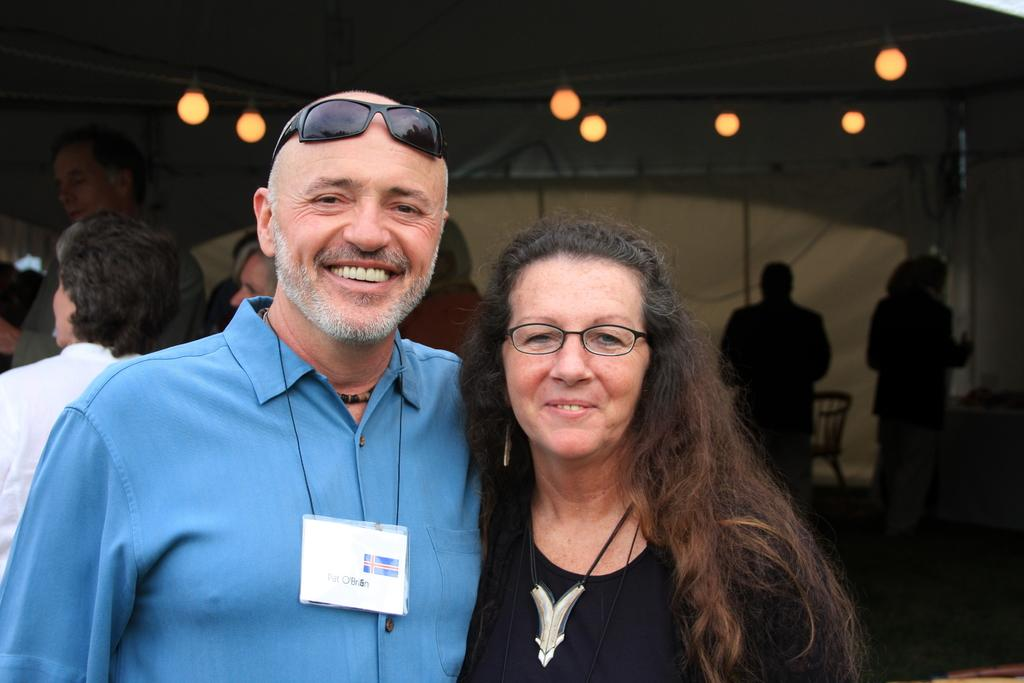What is the gender of the person in the image? There is a man in the image. What is the man doing in the image? The man is standing and smiling. What is the man wearing in the image? The man is wearing a blue shirt. Is there another person in the image? Yes, there is a woman in the image. What is the woman doing in the image? The woman is smiling. What is the woman wearing in the image? The woman is wearing a black dress. What can be seen at the top of the image? There are lights visible at the top of the image. How many girls are present in the image? There is no girl present in the image; it features a man and a woman. What type of page is visible in the image? There is no page present in the image. 